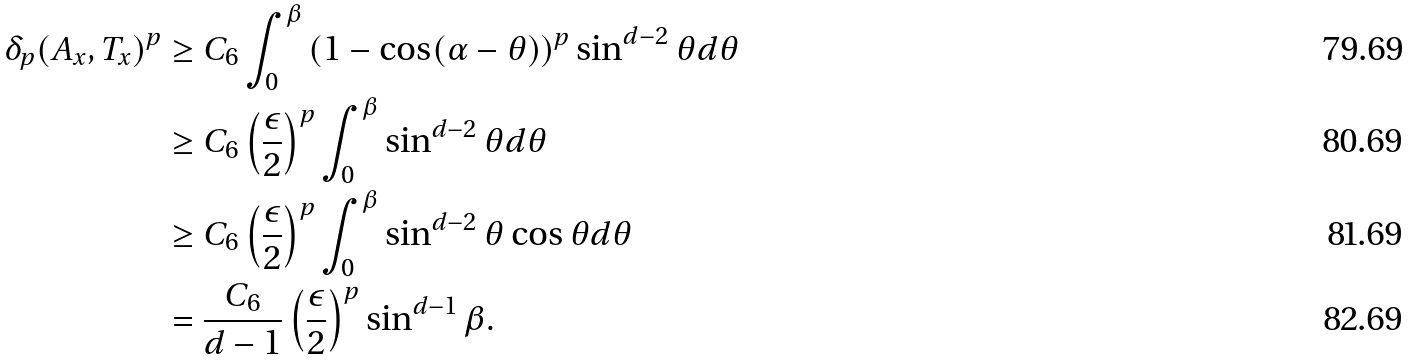Convert formula to latex. <formula><loc_0><loc_0><loc_500><loc_500>\delta _ { p } ( A _ { x } , T _ { x } ) ^ { p } & \geq C _ { 6 } \int _ { 0 } ^ { \beta } \left ( 1 - \cos ( \alpha - \theta ) \right ) ^ { p } \sin ^ { d - 2 } \theta d \theta \\ & \geq C _ { 6 } \left ( \frac { \epsilon } { 2 } \right ) ^ { p } \int _ { 0 } ^ { \beta } \sin ^ { d - 2 } \theta d \theta \\ & \geq C _ { 6 } \left ( \frac { \epsilon } { 2 } \right ) ^ { p } \int _ { 0 } ^ { \beta } \sin ^ { d - 2 } \theta \cos \theta d \theta \\ & = \frac { C _ { 6 } } { d - 1 } \left ( \frac { \epsilon } { 2 } \right ) ^ { p } \sin ^ { d - 1 } \beta .</formula> 